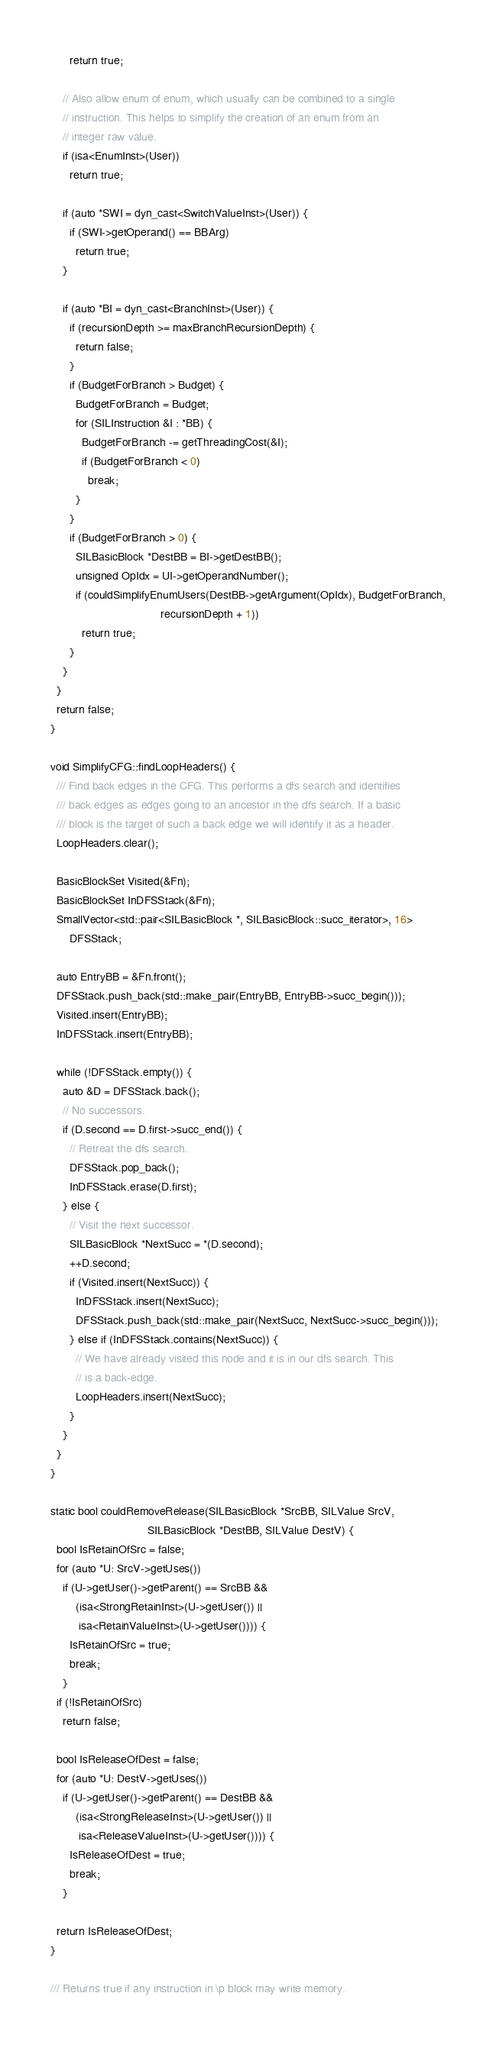Convert code to text. <code><loc_0><loc_0><loc_500><loc_500><_C++_>      return true;

    // Also allow enum of enum, which usually can be combined to a single
    // instruction. This helps to simplify the creation of an enum from an
    // integer raw value.
    if (isa<EnumInst>(User))
      return true;

    if (auto *SWI = dyn_cast<SwitchValueInst>(User)) {
      if (SWI->getOperand() == BBArg)
        return true;
    }

    if (auto *BI = dyn_cast<BranchInst>(User)) {
      if (recursionDepth >= maxBranchRecursionDepth) {
        return false;
      }
      if (BudgetForBranch > Budget) {
        BudgetForBranch = Budget;
        for (SILInstruction &I : *BB) {
          BudgetForBranch -= getThreadingCost(&I);
          if (BudgetForBranch < 0)
            break;
        }
      }
      if (BudgetForBranch > 0) {
        SILBasicBlock *DestBB = BI->getDestBB();
        unsigned OpIdx = UI->getOperandNumber();
        if (couldSimplifyEnumUsers(DestBB->getArgument(OpIdx), BudgetForBranch,
                                   recursionDepth + 1))
          return true;
      }
    }
  }
  return false;
}

void SimplifyCFG::findLoopHeaders() {
  /// Find back edges in the CFG. This performs a dfs search and identifies
  /// back edges as edges going to an ancestor in the dfs search. If a basic
  /// block is the target of such a back edge we will identify it as a header.
  LoopHeaders.clear();

  BasicBlockSet Visited(&Fn);
  BasicBlockSet InDFSStack(&Fn);
  SmallVector<std::pair<SILBasicBlock *, SILBasicBlock::succ_iterator>, 16>
      DFSStack;

  auto EntryBB = &Fn.front();
  DFSStack.push_back(std::make_pair(EntryBB, EntryBB->succ_begin()));
  Visited.insert(EntryBB);
  InDFSStack.insert(EntryBB);

  while (!DFSStack.empty()) {
    auto &D = DFSStack.back();
    // No successors.
    if (D.second == D.first->succ_end()) {
      // Retreat the dfs search.
      DFSStack.pop_back();
      InDFSStack.erase(D.first);
    } else {
      // Visit the next successor.
      SILBasicBlock *NextSucc = *(D.second);
      ++D.second;
      if (Visited.insert(NextSucc)) {
        InDFSStack.insert(NextSucc);
        DFSStack.push_back(std::make_pair(NextSucc, NextSucc->succ_begin()));
      } else if (InDFSStack.contains(NextSucc)) {
        // We have already visited this node and it is in our dfs search. This
        // is a back-edge.
        LoopHeaders.insert(NextSucc);
      }
    }
  }
}

static bool couldRemoveRelease(SILBasicBlock *SrcBB, SILValue SrcV,
                               SILBasicBlock *DestBB, SILValue DestV) {
  bool IsRetainOfSrc = false;
  for (auto *U: SrcV->getUses())
    if (U->getUser()->getParent() == SrcBB &&
        (isa<StrongRetainInst>(U->getUser()) ||
         isa<RetainValueInst>(U->getUser()))) {
      IsRetainOfSrc = true;
      break;
    }
  if (!IsRetainOfSrc)
    return false;

  bool IsReleaseOfDest = false;
  for (auto *U: DestV->getUses())
    if (U->getUser()->getParent() == DestBB &&
        (isa<StrongReleaseInst>(U->getUser()) ||
         isa<ReleaseValueInst>(U->getUser()))) {
      IsReleaseOfDest = true;
      break;
    }

  return IsReleaseOfDest;
}

/// Returns true if any instruction in \p block may write memory.</code> 